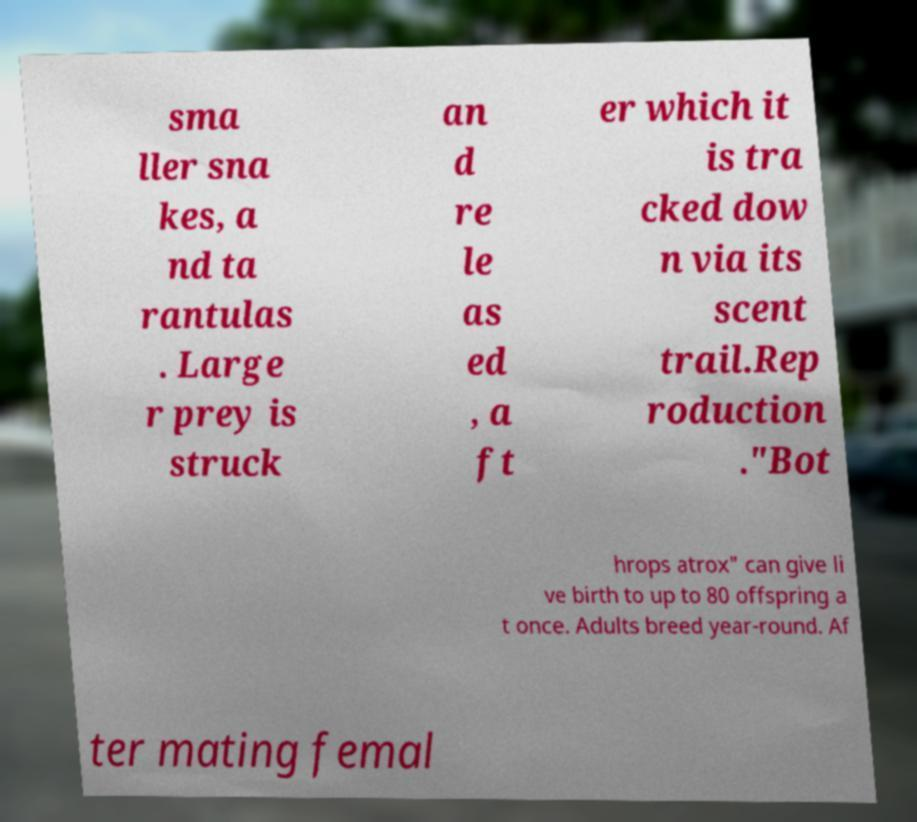Can you read and provide the text displayed in the image?This photo seems to have some interesting text. Can you extract and type it out for me? sma ller sna kes, a nd ta rantulas . Large r prey is struck an d re le as ed , a ft er which it is tra cked dow n via its scent trail.Rep roduction ."Bot hrops atrox" can give li ve birth to up to 80 offspring a t once. Adults breed year-round. Af ter mating femal 